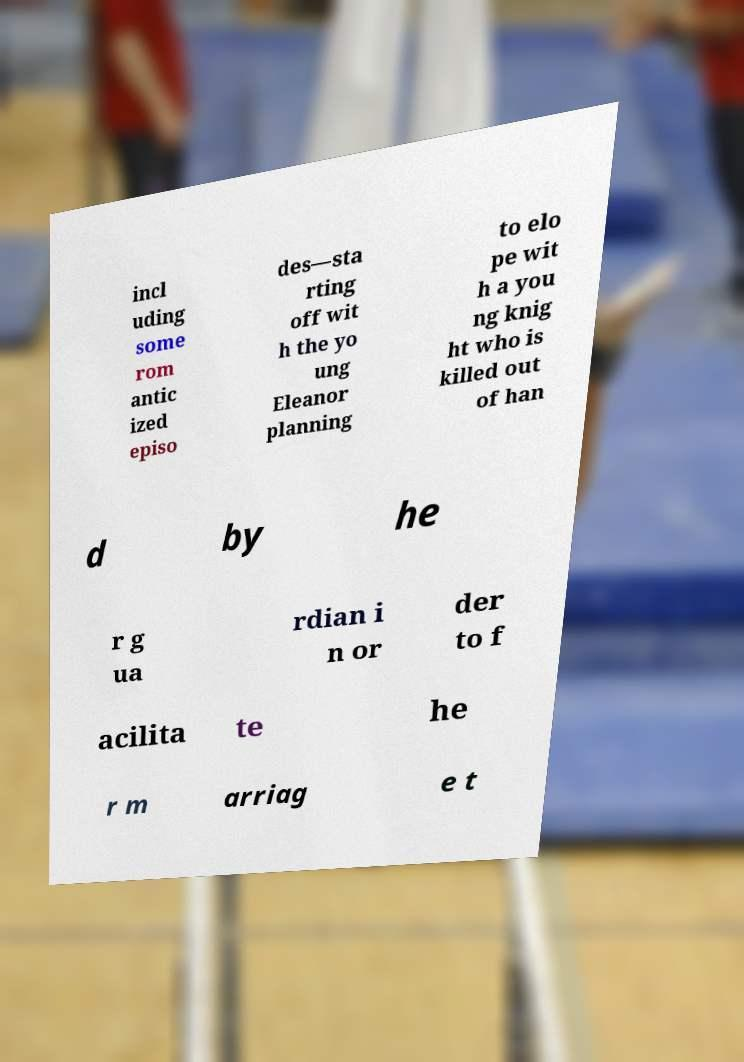Could you assist in decoding the text presented in this image and type it out clearly? incl uding some rom antic ized episo des—sta rting off wit h the yo ung Eleanor planning to elo pe wit h a you ng knig ht who is killed out of han d by he r g ua rdian i n or der to f acilita te he r m arriag e t 